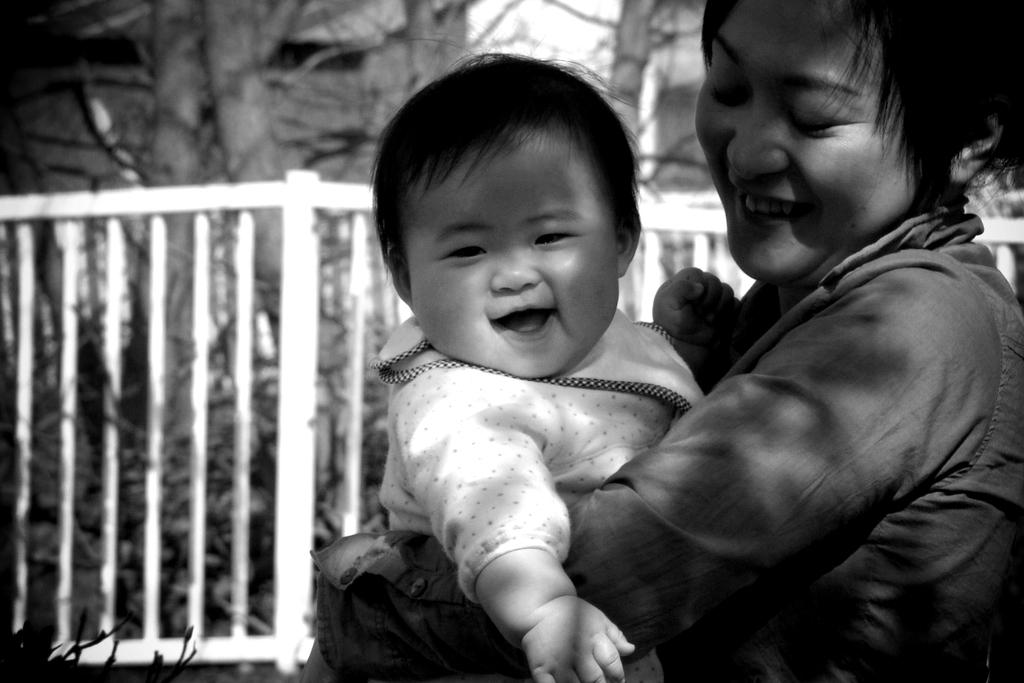What is the color scheme of the image? The image is black and white. Who is present in the image? There is a woman in the image. What is the woman doing in the image? The woman is carrying a baby. How is the baby being held by the woman? The baby is in the woman's hands. What expressions do the woman and the baby have in the image? Both the woman and the baby are smiling. What can be seen in the background of the image? There is a railing and trees in the background of the image. What type of pet is visible in the woman's elbow in the image? There is no pet visible in the woman's elbow in the image. What kind of cloud can be seen in the background of the image? The image is black and white, so it is not possible to determine the type of cloud in the background. 